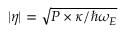Convert formula to latex. <formula><loc_0><loc_0><loc_500><loc_500>| \eta | = \sqrt { P \times \kappa / \hbar { \omega } _ { E } }</formula> 